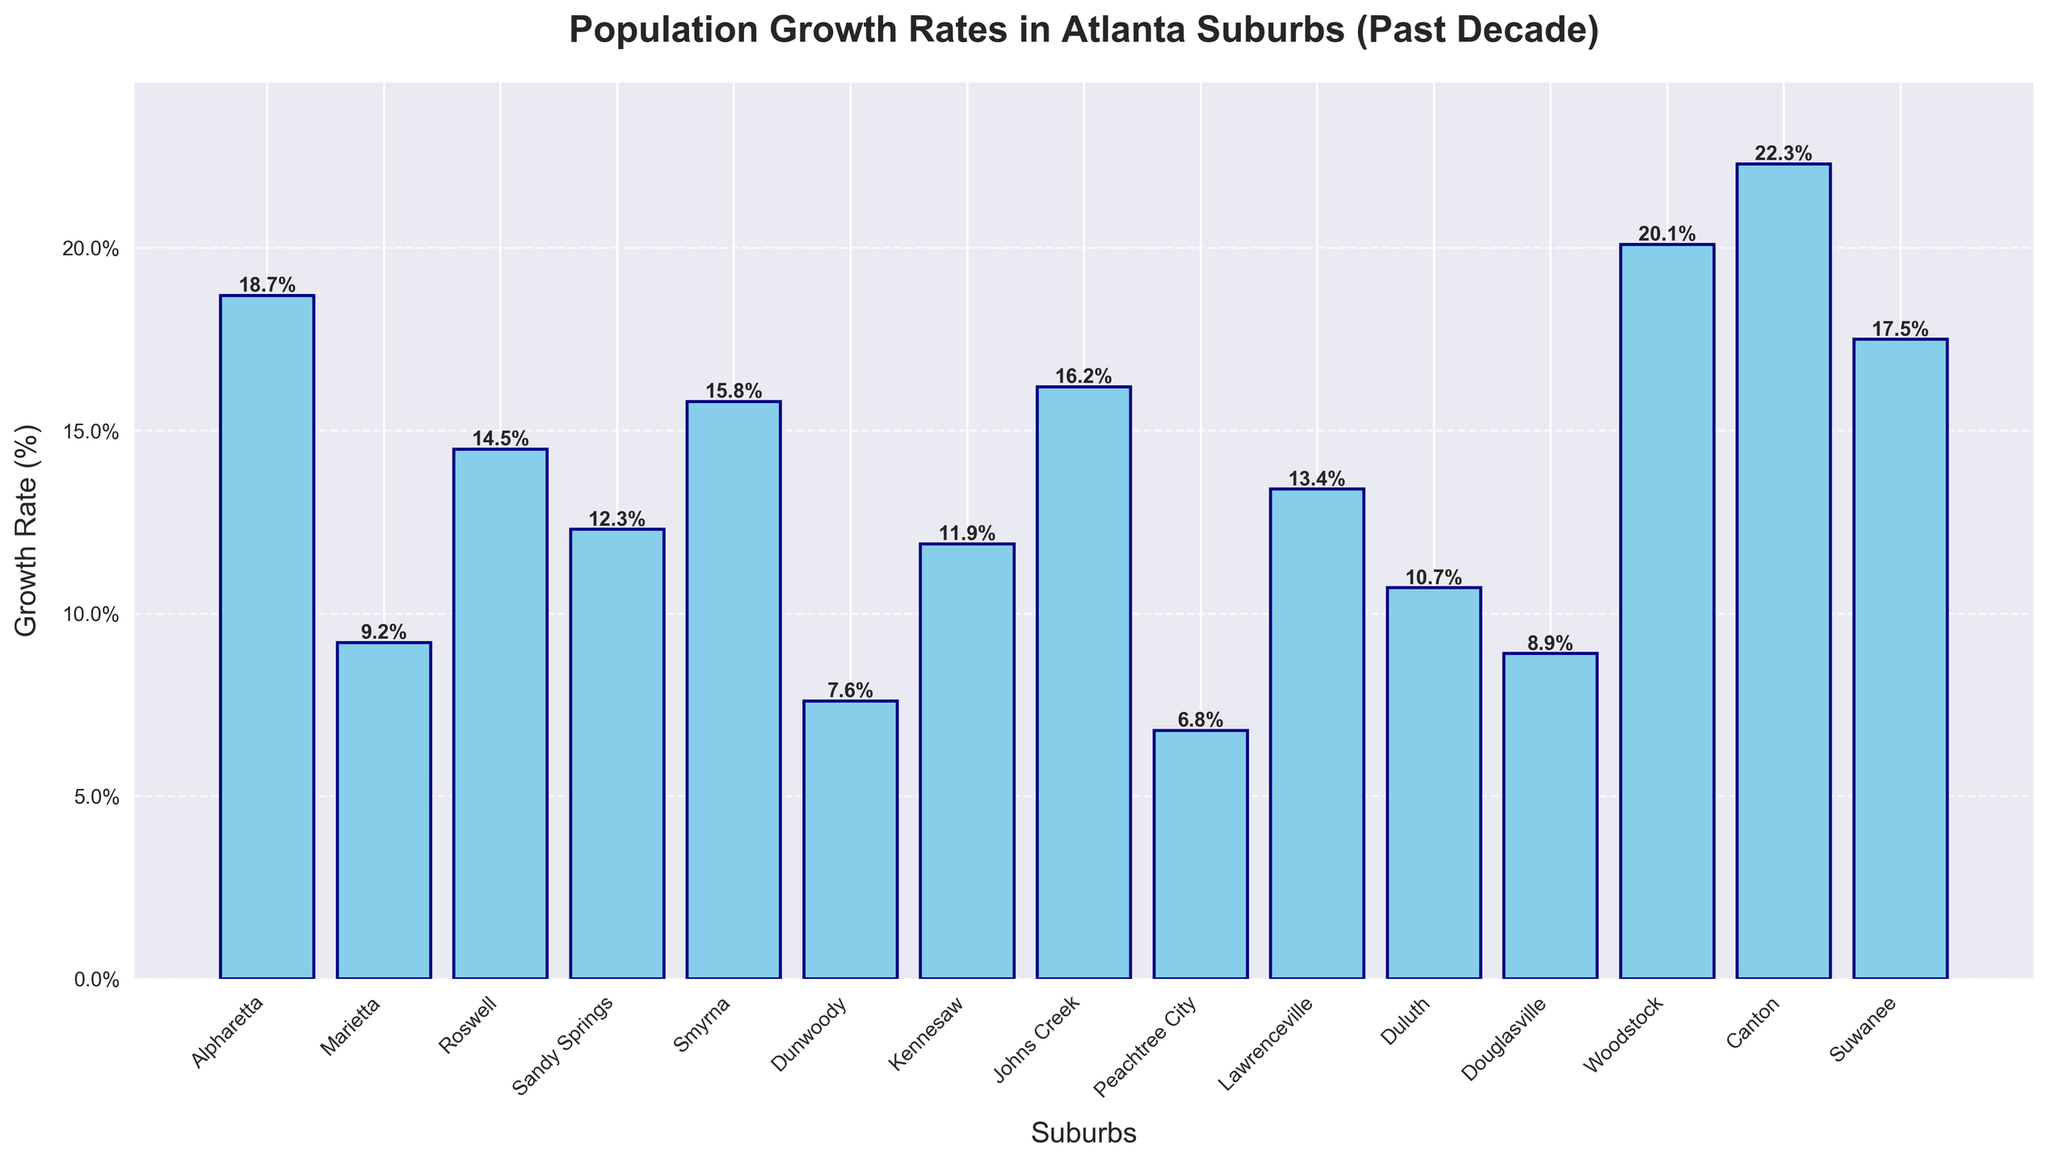Which suburb has the highest population growth rate? By observing the highest bar in the figure, we can determine the suburb with the highest growth rate. The tallest bar corresponds to Canton.
Answer: Canton Which suburb has the lowest population growth rate? By identifying the shortest bar in the figure, we can determine the suburb with the lowest growth rate. The shortest bar corresponds to Peachtree City.
Answer: Peachtree City How does Woodstock's growth rate compare to Alpharetta's? By comparing the heights of the bars for Woodstock and Alpharetta, we can see that the bar for Woodstock is taller than the bar for Alpharetta. Thus, Woodstock's growth rate is higher.
Answer: Woodstock's growth rate is higher What's the average growth rate of Roswell, Sandy Springs, and Smyrna? Sum the growth rates of Roswell (14.5%), Sandy Springs (12.3%), and Smyrna (15.8%), and then divide by 3. (14.5 + 12.3 + 15.8) / 3 ≈ 14.2%
Answer: 14.2% Which suburbs have growth rates higher than 15%? By examining the bars surpassing the 15% mark, we identify Alpharetta (18.7%), Smyrna (15.8%), Johns Creek (16.2%), Woodstock (20.1%), Canton (22.3%), and Suwanee (17.5%).
Answer: Alpharetta, Smyrna, Johns Creek, Woodstock, Canton, Suwanee What is the difference in growth rate between Kennesaw and Duluth? Subtract the growth rate of Duluth (10.7%) from Kennesaw's (11.9%). 11.9 - 10.7 = 1.2%
Answer: 1.2% Rank the suburbs in decreasing order of their growth rates? From highest to lowest: Canton (22.3%), Woodstock (20.1%), Alpharetta (18.7%), Suwanee (17.5%), Johns Creek (16.2%), Smyrna (15.8%), Roswell (14.5%), Lawrenceville (13.4%), Sandy Springs (12.3%), Kennesaw (11.9%), Duluth (10.7%), Marietta (9.2%), Douglasville (8.9%), Dunwoody (7.6%), Peachtree City (6.8%).
Answer: Canton, Woodstock, Alpharetta, Suwanee, Johns Creek, Smyrna, Roswell, Lawrenceville, Sandy Springs, Kennesaw, Duluth, Marietta, Douglasville, Dunwoody, Peachtree City Is the growth rate of Marietta greater than the growth rate of Dunwoody? Comparing the heights of the bars for Marietta (9.2%) and Dunwoody (7.6%), Marietta's bar is taller.
Answer: Yes What's the combined growth rate of the top 3 fastest-growing suburbs? Add the growth rates of the top three fastest-growing suburbs: Canton (22.3%), Woodstock (20.1%), and Alpharetta (18.7%). 22.3 + 20.1 + 18.7 = 61.1%
Answer: 61.1% Which suburb has slightly less than a 10% growth rate, and what is that exact rate? Observing the suburbs with growth rates near 10%, Douglasville has a growth rate of 8.9%, which is slightly less than 10%.
Answer: Douglasville, 8.9% 